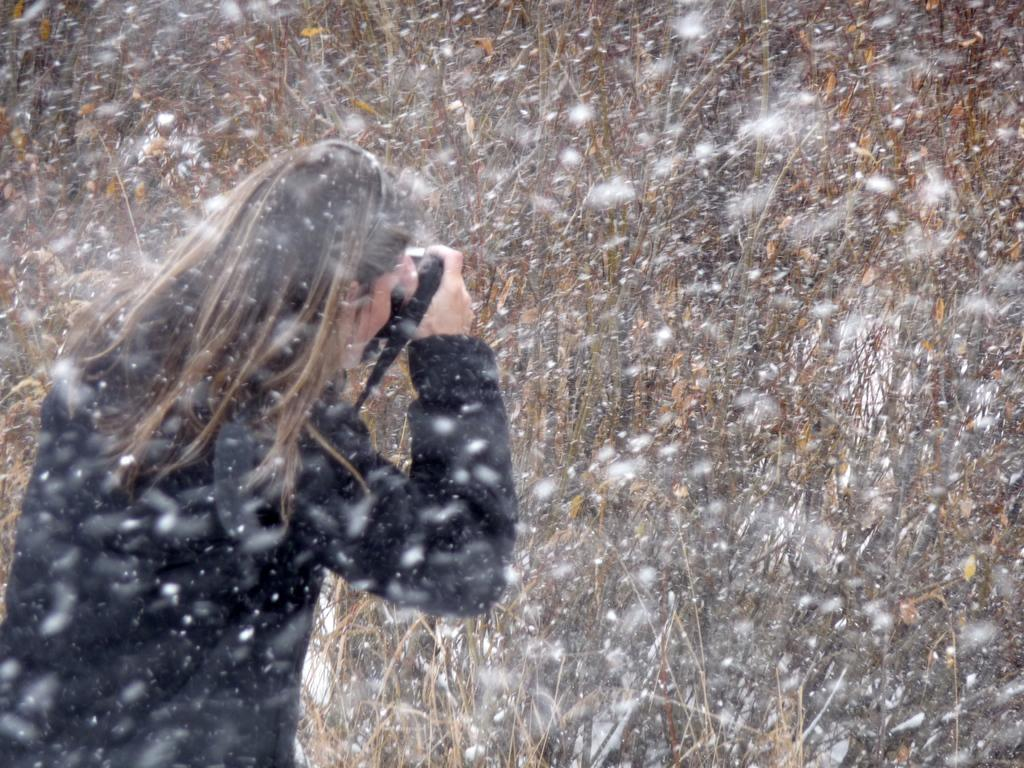Who is the main subject in the image? There is a woman in the image. What is the woman holding in the image? The woman is holding a camera. What type of weather can be seen in the background of the image? There is snowfall in the background of the image. What type of vegetation is visible in the background of the image? Grass is visible in the background of the image. What industry does the woman work in, as seen in the image? There is no information in the image to determine the woman's industry. 